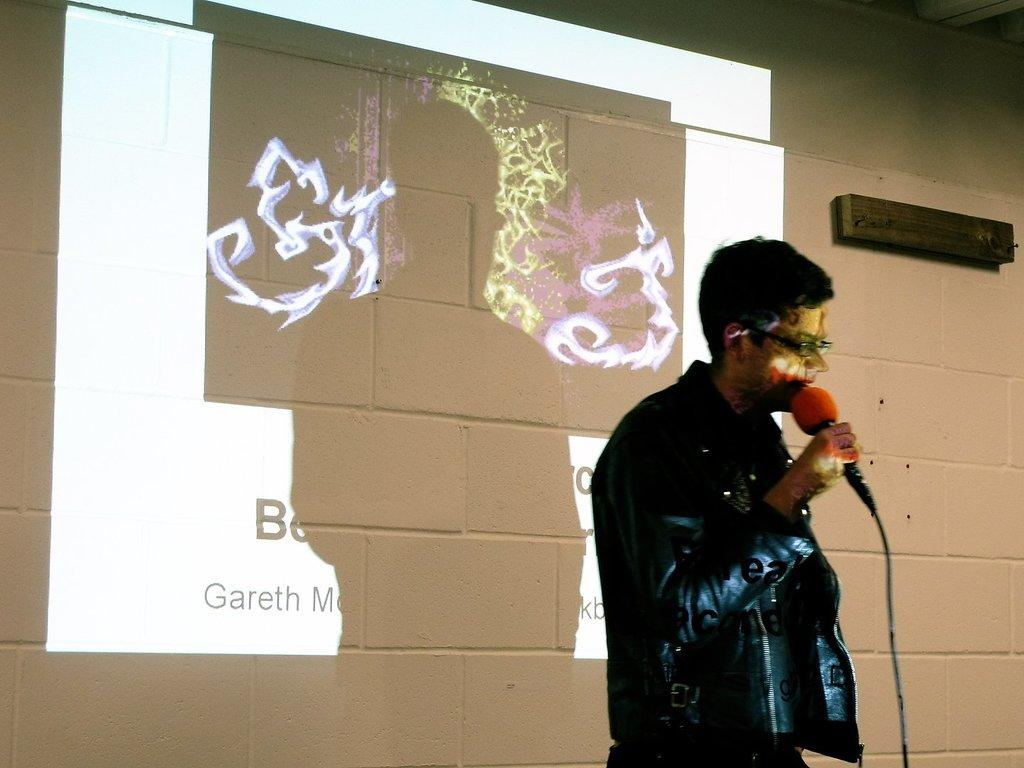What is the main subject of the image? There is a person in the image. What object is the person using? There is a microphone in the image. What can be seen in the background of the image? There is a wall, a projector screen, and an unspecified object in the background of the image. How many books are visible on the island in the image? There is no island or books present in the image. What type of crow can be seen interacting with the unspecified object in the image? There is no crow present in the image; only the person, microphone, wall, projector screen, and unspecified object are visible. 